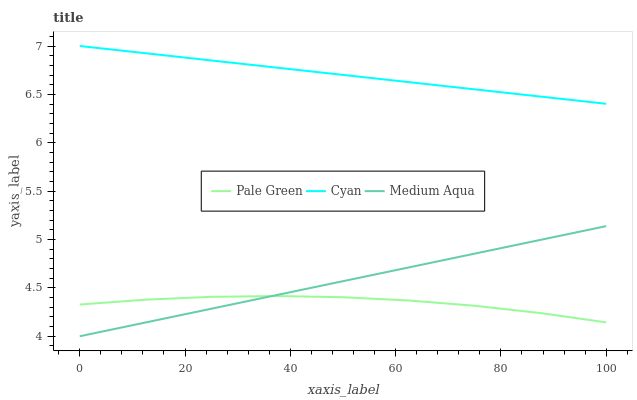Does Medium Aqua have the minimum area under the curve?
Answer yes or no. No. Does Medium Aqua have the maximum area under the curve?
Answer yes or no. No. Is Medium Aqua the smoothest?
Answer yes or no. No. Is Medium Aqua the roughest?
Answer yes or no. No. Does Pale Green have the lowest value?
Answer yes or no. No. Does Medium Aqua have the highest value?
Answer yes or no. No. Is Medium Aqua less than Cyan?
Answer yes or no. Yes. Is Cyan greater than Medium Aqua?
Answer yes or no. Yes. Does Medium Aqua intersect Cyan?
Answer yes or no. No. 